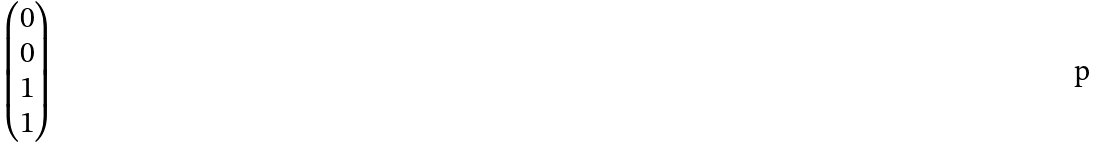<formula> <loc_0><loc_0><loc_500><loc_500>\begin{pmatrix} 0 \\ 0 \\ 1 \\ 1 \end{pmatrix}</formula> 